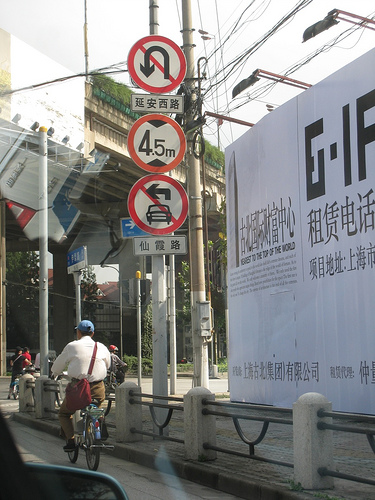Please extract the text content from this image. 4.5m IF G 